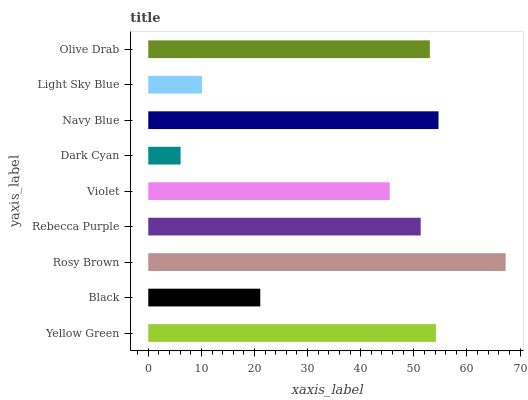Is Dark Cyan the minimum?
Answer yes or no. Yes. Is Rosy Brown the maximum?
Answer yes or no. Yes. Is Black the minimum?
Answer yes or no. No. Is Black the maximum?
Answer yes or no. No. Is Yellow Green greater than Black?
Answer yes or no. Yes. Is Black less than Yellow Green?
Answer yes or no. Yes. Is Black greater than Yellow Green?
Answer yes or no. No. Is Yellow Green less than Black?
Answer yes or no. No. Is Rebecca Purple the high median?
Answer yes or no. Yes. Is Rebecca Purple the low median?
Answer yes or no. Yes. Is Rosy Brown the high median?
Answer yes or no. No. Is Navy Blue the low median?
Answer yes or no. No. 